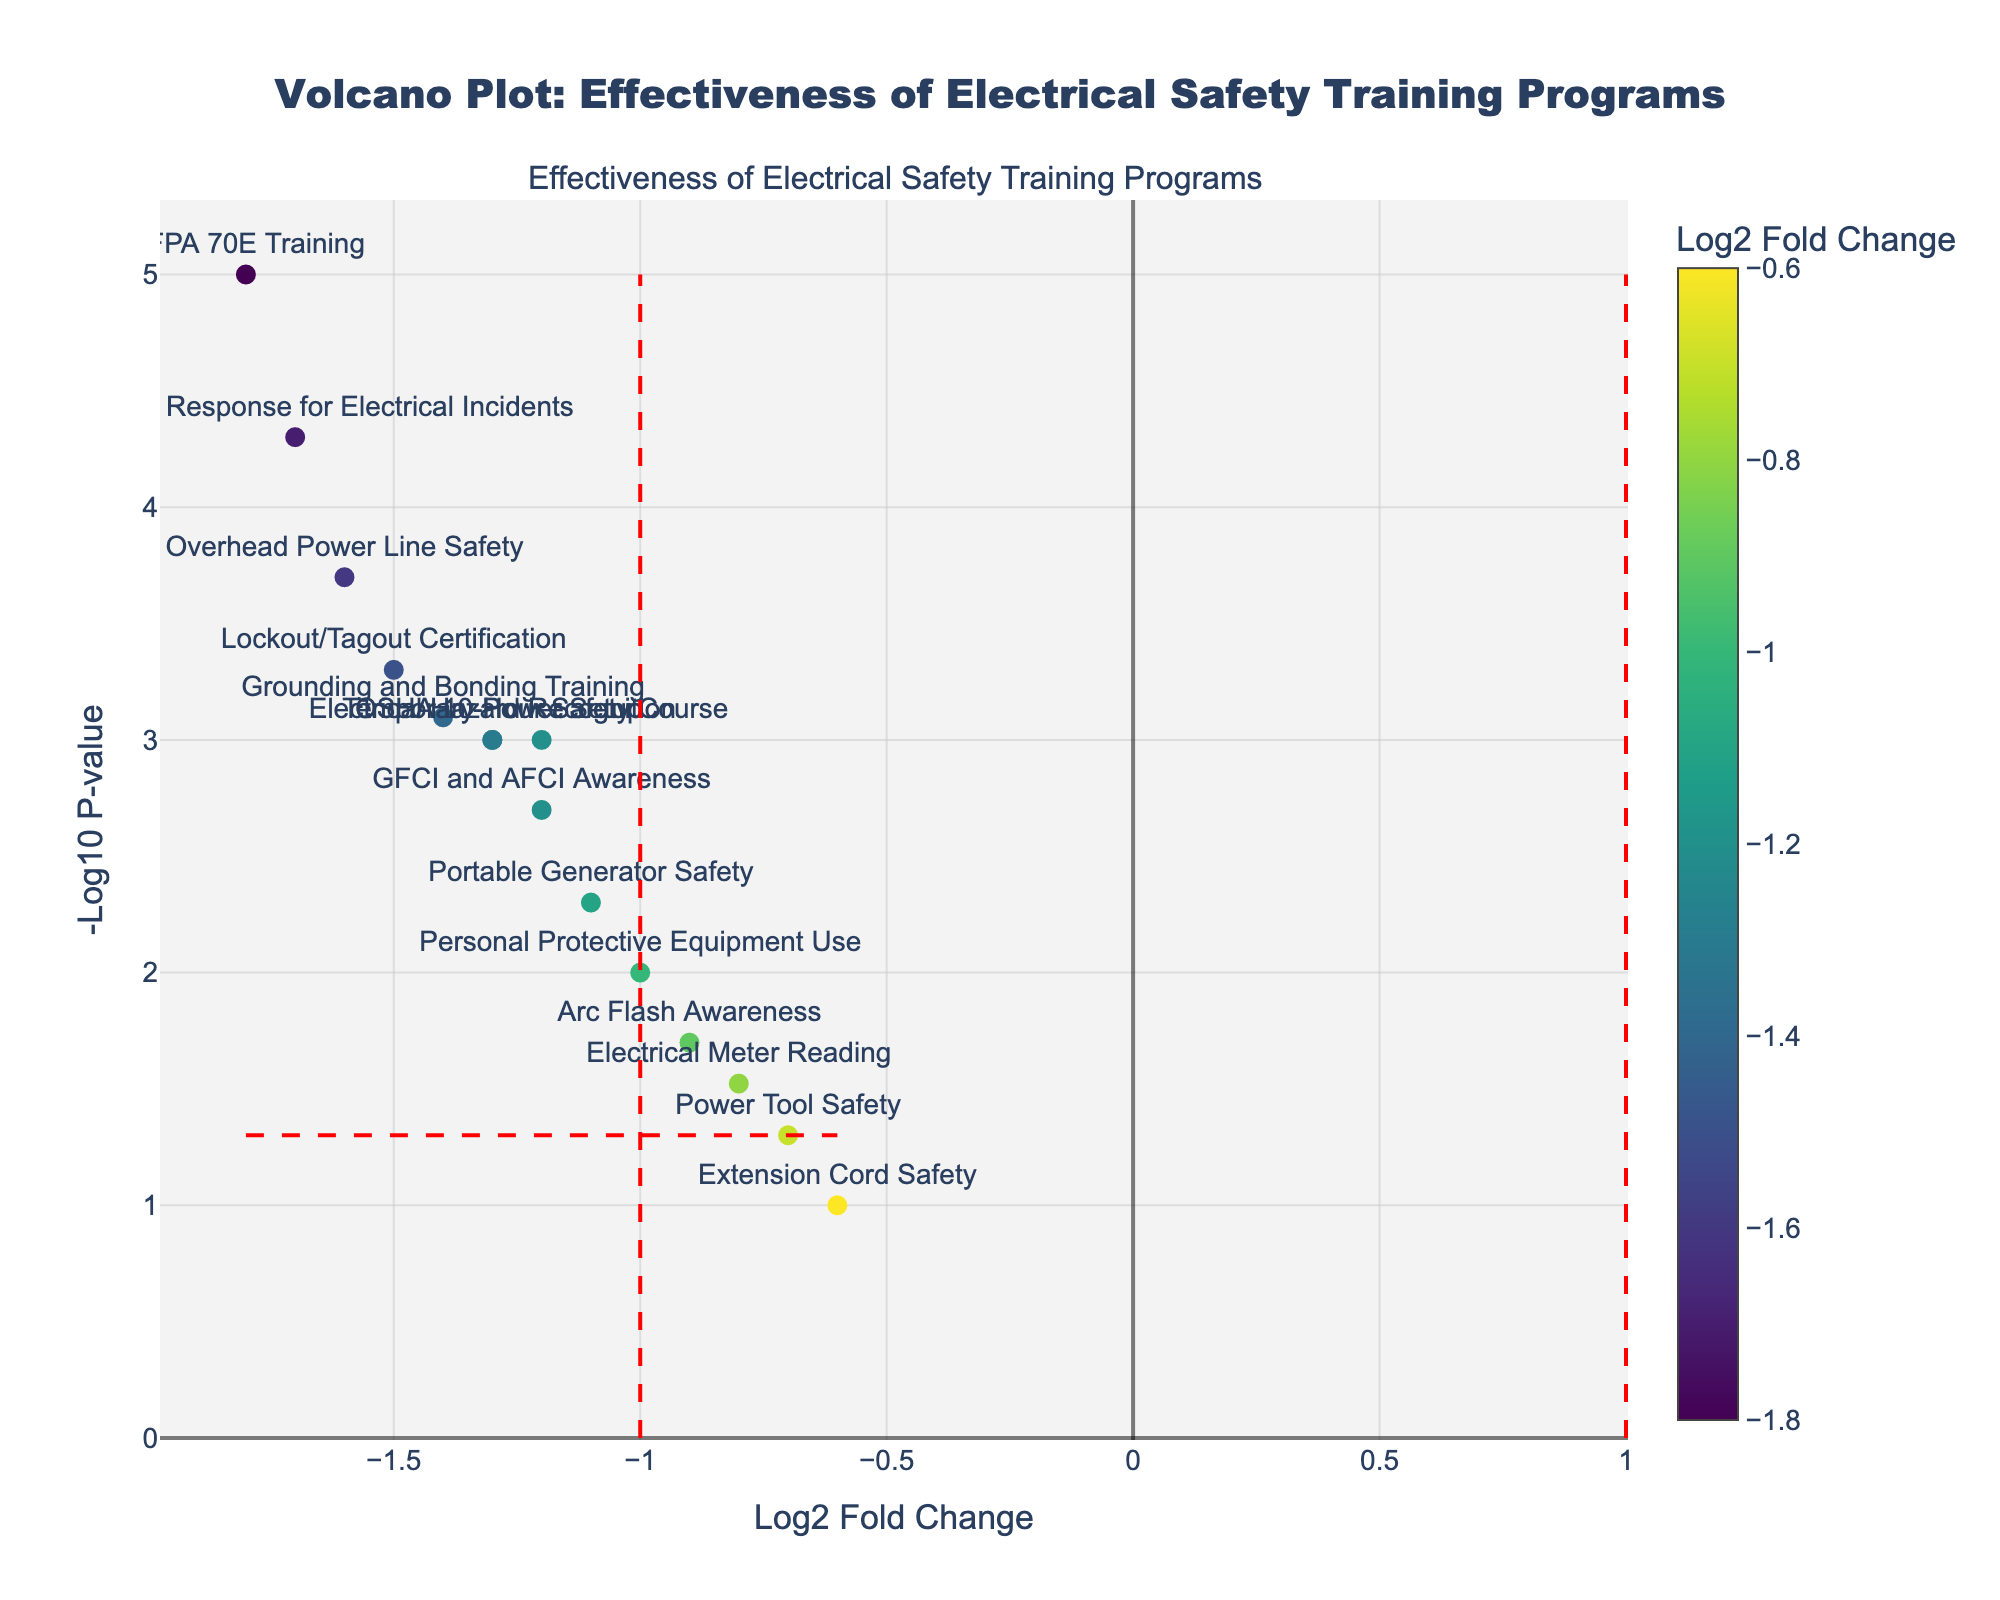what is the title of the figure? The title is usually located at the top of the figure and describes the content or purpose of the plot. By reading the title, you can understand that the figure is about the effectiveness of different electrical safety training programs.
Answer: Volcano Plot: Effectiveness of Electrical Safety Training Programs Which program has the highest log2 fold change reduction in injury rates? To find the program with the highest log2 fold change reduction, look at the x-axis for the most negative value. From the scatter points, it is evident that "NFPA 70E Training" has the most negative log2 fold change, indicating it is the most effective.
Answer: NFPA 70E Training Which program has the smallest p-value? The smallest p-value corresponds to the highest value on the y-axis (-log10(p-value)). Identify the point located highest on the y-axis to find the program. "NFPA 70E Training" is the highest point on the y-axis, indicating it has the smallest p-value.
Answer: NFPA 70E Training How many training programs had a statistically significant reduction in injury rates at the p-value threshold of 0.05? Determine the number of points above the horizontal red dashed line, representing the -log10(0.05) threshold for significance. Count the points above this line to find the number of programs with statistically significant reductions in injury rates.
Answer: 12 Which training programs are closest to the log2 fold change values of ±1? Look for the points near the vertical red dashed lines at ±1 on the x-axis. By inspecting the scatter points around these thresholds, "Extension Cord Safety" and "Personal Protective Equipment Use" are closest to these lines on either side.
Answer: Extension Cord Safety and Personal Protective Equipment Use What is the log2 fold change and p-value for "Arc Flash Awareness"? Locate the point labeled "Arc Flash Awareness" on the plot to find its position on the x-axis (log2 fold change) and y-axis (-log10 p-value). The hover text will aid in identifying the exact values.
Answer: -0.9, 0.02 Which program has the second highest log2 fold change reduction in injury rates? Identify the second most negative value on the x-axis after "NFPA 70E Training." By observing the points, "Emergency Response for Electrical Incidents" is the second most negative, indicating the second highest reduction.
Answer: Emergency Response for Electrical Incidents How does "Power Tool Safety" compare in effectiveness to "Grounding and Bonding Training"? Compare "Power Tool Safety" and "Grounding and Bonding Training" by locating their points on the plot. "Grounding and Bonding Training" has a more negative log2 fold change and a higher -log10 p-value, suggesting it is more effective in both metrics.
Answer: Grounding and Bonding Training is more effective What is the average log2 fold change for the programs with a p-value less than 0.001? Identify the points with a y-axis value greater than -log10(0.001), then average their x-axis values (log2 fold changes). The relevant programs are "NFPA 70E Training," "Emergency Response for Electrical Incidents," "Overhead Power Line Safety," "Grounding and Bonding Training," "Lockout/Tagout Certification," "Temporary Power Setup," and "Electrical Hazard Recognition." Sum their log2 fold changes and divide by the number of programs. Average = (-1.8 - 1.7 - 1.6 - 1.4 - 1.5 - 1.3 - 1.3) / 7 = -1.51
Answer: -1.51 